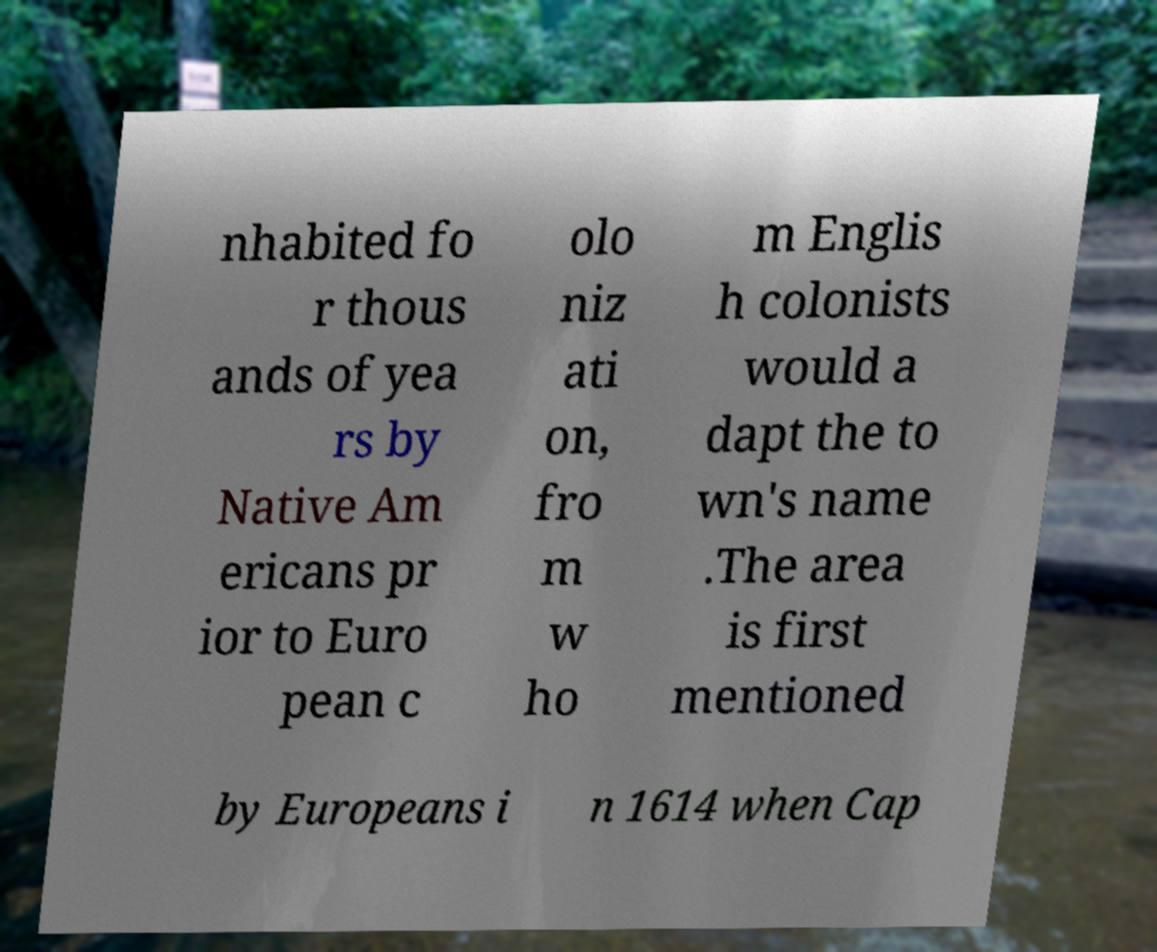Could you assist in decoding the text presented in this image and type it out clearly? nhabited fo r thous ands of yea rs by Native Am ericans pr ior to Euro pean c olo niz ati on, fro m w ho m Englis h colonists would a dapt the to wn's name .The area is first mentioned by Europeans i n 1614 when Cap 